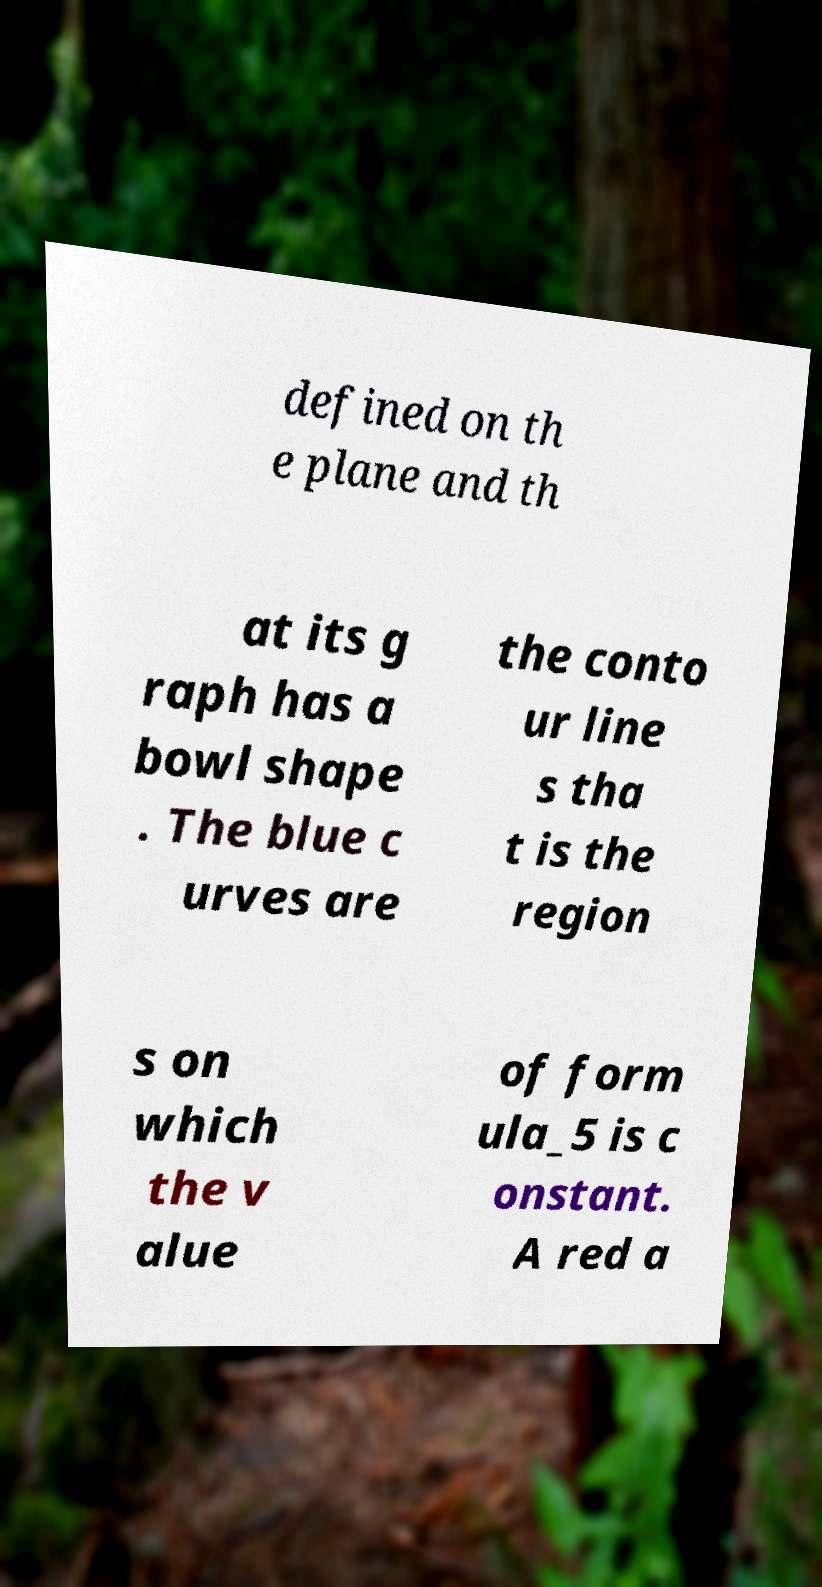I need the written content from this picture converted into text. Can you do that? defined on th e plane and th at its g raph has a bowl shape . The blue c urves are the conto ur line s tha t is the region s on which the v alue of form ula_5 is c onstant. A red a 